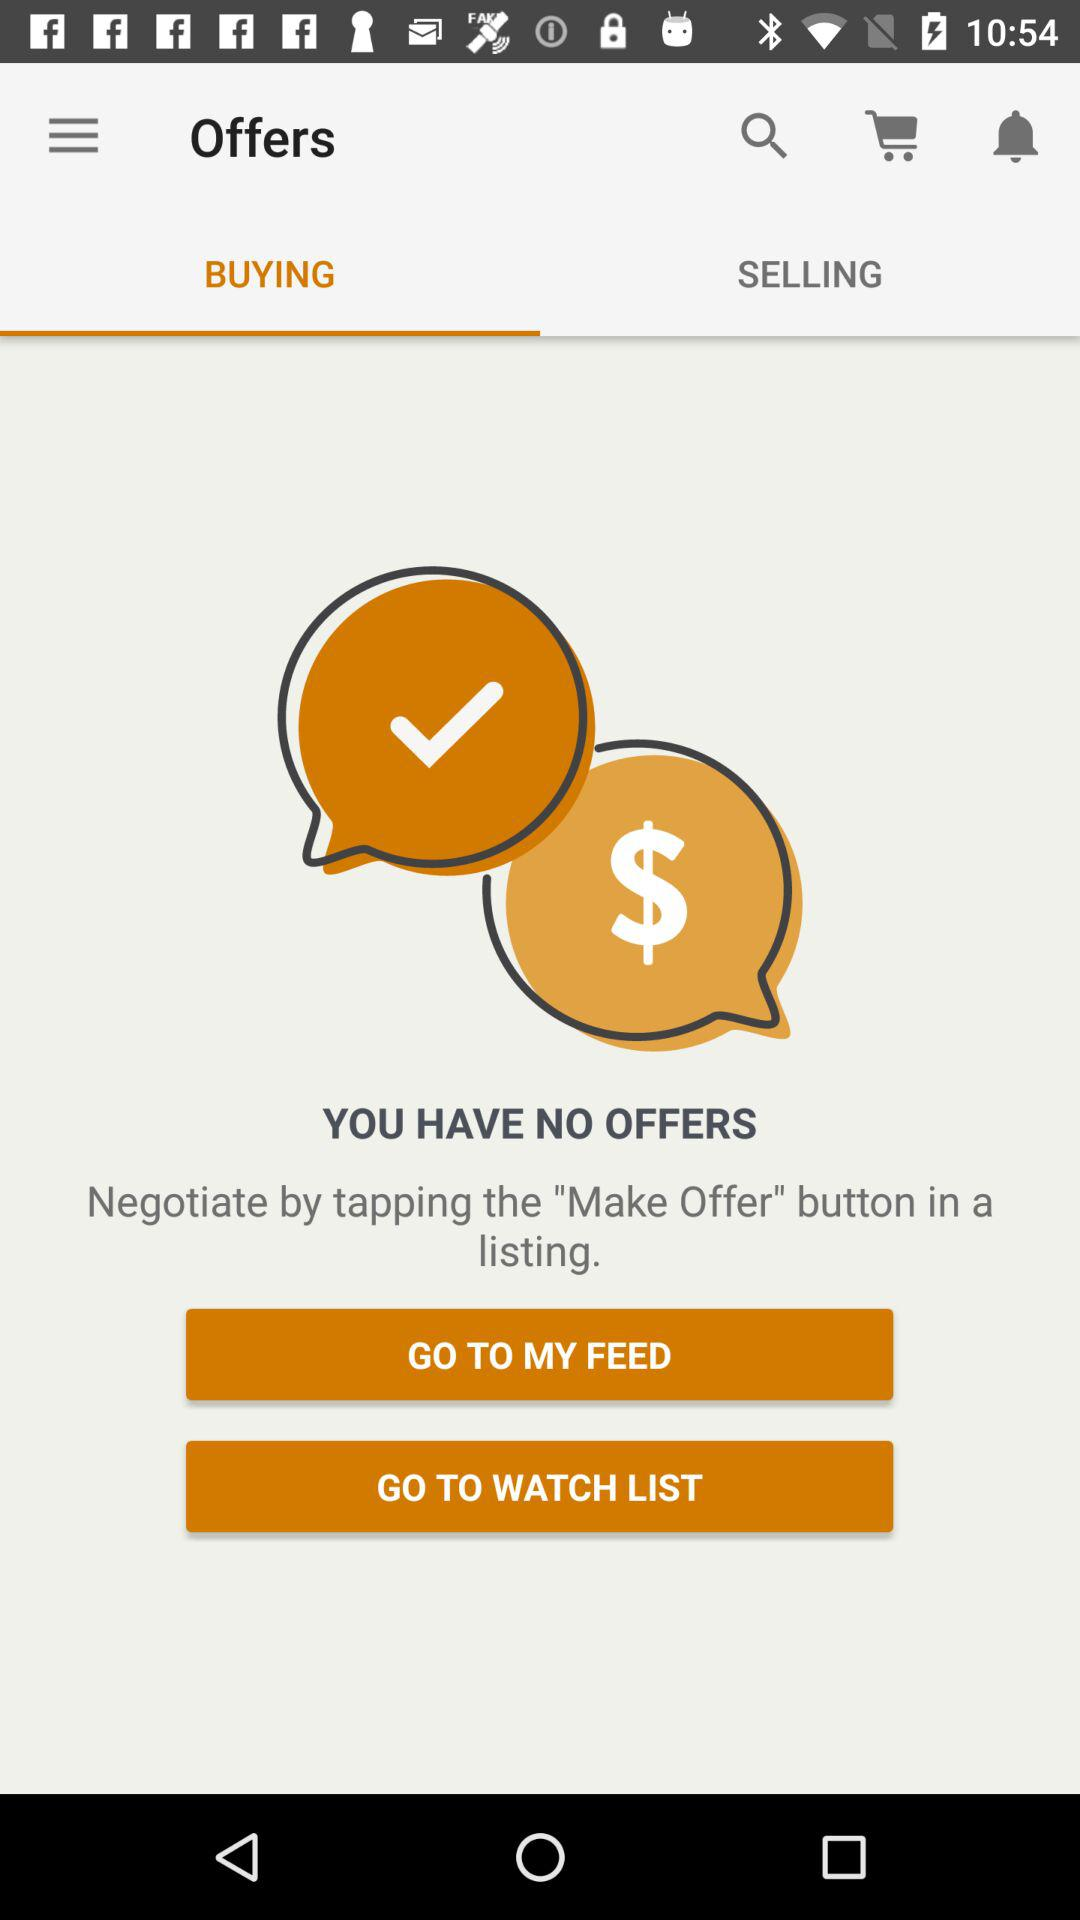Are there any offers available? There are no available offers. 